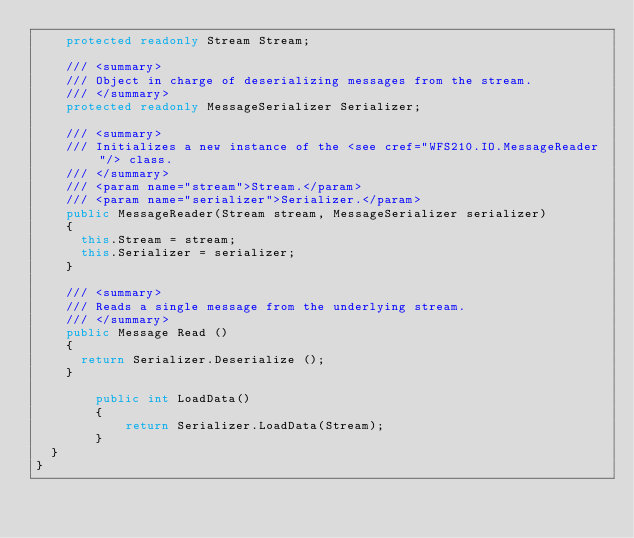Convert code to text. <code><loc_0><loc_0><loc_500><loc_500><_C#_>		protected readonly Stream Stream;

		/// <summary>
		/// Object in charge of deserializing messages from the stream.
		/// </summary>
		protected readonly MessageSerializer Serializer;

		/// <summary>
		/// Initializes a new instance of the <see cref="WFS210.IO.MessageReader"/> class.
		/// </summary>
		/// <param name="stream">Stream.</param>
		/// <param name="serializer">Serializer.</param>
		public MessageReader(Stream stream, MessageSerializer serializer)
		{
			this.Stream = stream;
			this.Serializer = serializer;
		}

		/// <summary>
		/// Reads a single message from the underlying stream.
		/// </summary>
		public Message Read ()
		{
			return Serializer.Deserialize ();
		}

        public int LoadData()
        {
            return Serializer.LoadData(Stream);
        }
	}
}

</code> 